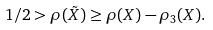<formula> <loc_0><loc_0><loc_500><loc_500>1 / 2 > \rho ( \tilde { X } ) \geq \rho ( X ) - \rho _ { 3 } ( X ) .</formula> 